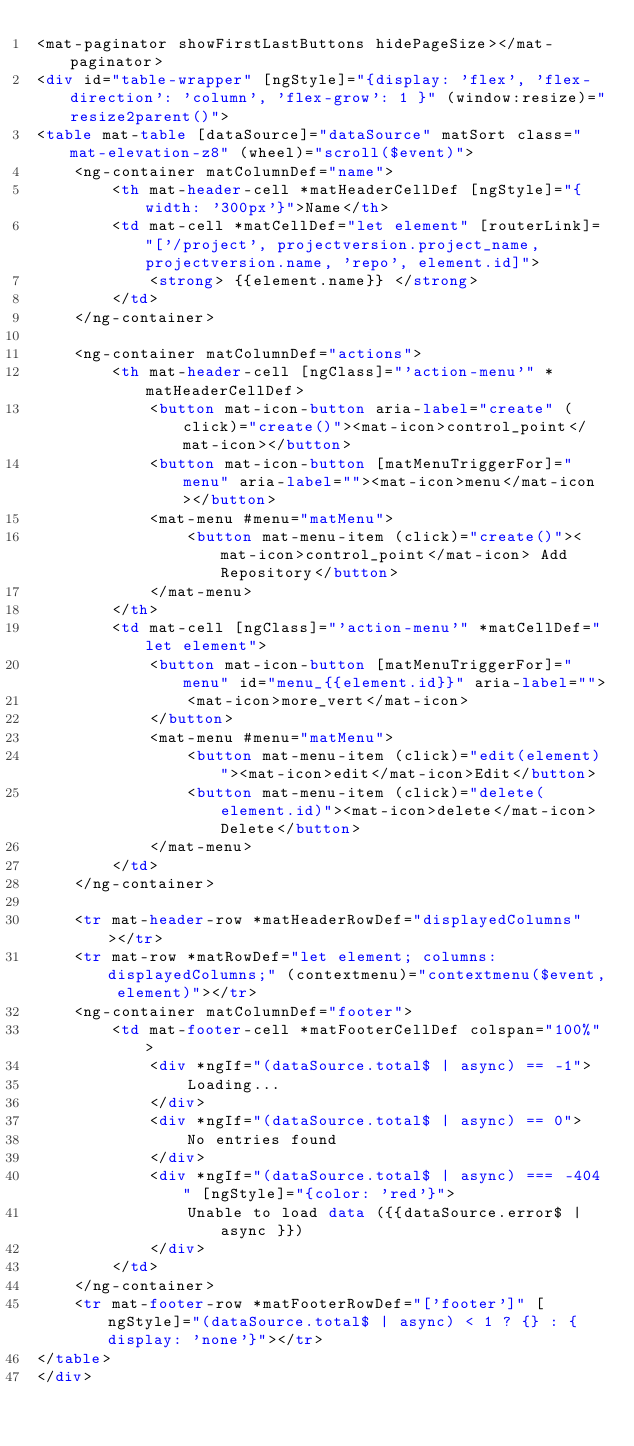<code> <loc_0><loc_0><loc_500><loc_500><_HTML_><mat-paginator showFirstLastButtons hidePageSize></mat-paginator>
<div id="table-wrapper" [ngStyle]="{display: 'flex', 'flex-direction': 'column', 'flex-grow': 1 }" (window:resize)="resize2parent()">
<table mat-table [dataSource]="dataSource" matSort class="mat-elevation-z8" (wheel)="scroll($event)">
    <ng-container matColumnDef="name">
        <th mat-header-cell *matHeaderCellDef [ngStyle]="{width: '300px'}">Name</th>
        <td mat-cell *matCellDef="let element" [routerLink]="['/project', projectversion.project_name, projectversion.name, 'repo', element.id]">
            <strong> {{element.name}} </strong>
        </td>
    </ng-container>

    <ng-container matColumnDef="actions">
        <th mat-header-cell [ngClass]="'action-menu'" *matHeaderCellDef>
            <button mat-icon-button aria-label="create" (click)="create()"><mat-icon>control_point</mat-icon></button>
            <button mat-icon-button [matMenuTriggerFor]="menu" aria-label=""><mat-icon>menu</mat-icon></button>
            <mat-menu #menu="matMenu">
                <button mat-menu-item (click)="create()"><mat-icon>control_point</mat-icon> Add Repository</button>
            </mat-menu>
        </th>
        <td mat-cell [ngClass]="'action-menu'" *matCellDef="let element">
            <button mat-icon-button [matMenuTriggerFor]="menu" id="menu_{{element.id}}" aria-label="">
                <mat-icon>more_vert</mat-icon>
            </button>
            <mat-menu #menu="matMenu">
                <button mat-menu-item (click)="edit(element)"><mat-icon>edit</mat-icon>Edit</button>
                <button mat-menu-item (click)="delete(element.id)"><mat-icon>delete</mat-icon>Delete</button>
            </mat-menu>
        </td>
    </ng-container>

    <tr mat-header-row *matHeaderRowDef="displayedColumns"></tr>
    <tr mat-row *matRowDef="let element; columns: displayedColumns;" (contextmenu)="contextmenu($event, element)"></tr>
    <ng-container matColumnDef="footer">
        <td mat-footer-cell *matFooterCellDef colspan="100%">
            <div *ngIf="(dataSource.total$ | async) == -1">
                Loading...
            </div>
            <div *ngIf="(dataSource.total$ | async) == 0">
                No entries found
            </div>
            <div *ngIf="(dataSource.total$ | async) === -404" [ngStyle]="{color: 'red'}">
                Unable to load data ({{dataSource.error$ | async }})
            </div>
        </td>
    </ng-container>
    <tr mat-footer-row *matFooterRowDef="['footer']" [ngStyle]="(dataSource.total$ | async) < 1 ? {} : {display: 'none'}"></tr>
</table>
</div>
</code> 